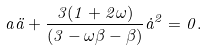Convert formula to latex. <formula><loc_0><loc_0><loc_500><loc_500>a \ddot { a } + \frac { 3 ( 1 + 2 \omega ) } { ( 3 - \omega \beta - \beta ) } { \dot { a } } ^ { 2 } = 0 .</formula> 